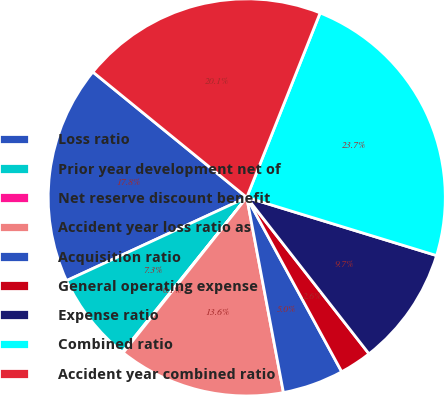<chart> <loc_0><loc_0><loc_500><loc_500><pie_chart><fcel>Loss ratio<fcel>Prior year development net of<fcel>Net reserve discount benefit<fcel>Accident year loss ratio as<fcel>Acquisition ratio<fcel>General operating expense<fcel>Expense ratio<fcel>Combined ratio<fcel>Accident year combined ratio<nl><fcel>17.77%<fcel>7.34%<fcel>0.08%<fcel>13.65%<fcel>4.98%<fcel>2.62%<fcel>9.71%<fcel>23.71%<fcel>20.14%<nl></chart> 